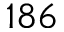<formula> <loc_0><loc_0><loc_500><loc_500>1 8 6</formula> 